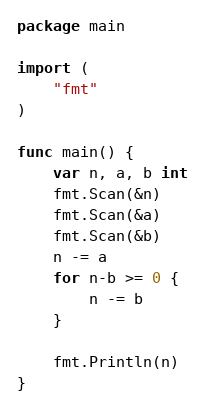Convert code to text. <code><loc_0><loc_0><loc_500><loc_500><_Go_>package main

import (
	"fmt"
)

func main() {
	var n, a, b int
	fmt.Scan(&n)
	fmt.Scan(&a)
	fmt.Scan(&b)
	n -= a
	for n-b >= 0 {
		n -= b
	}

	fmt.Println(n)
}
</code> 